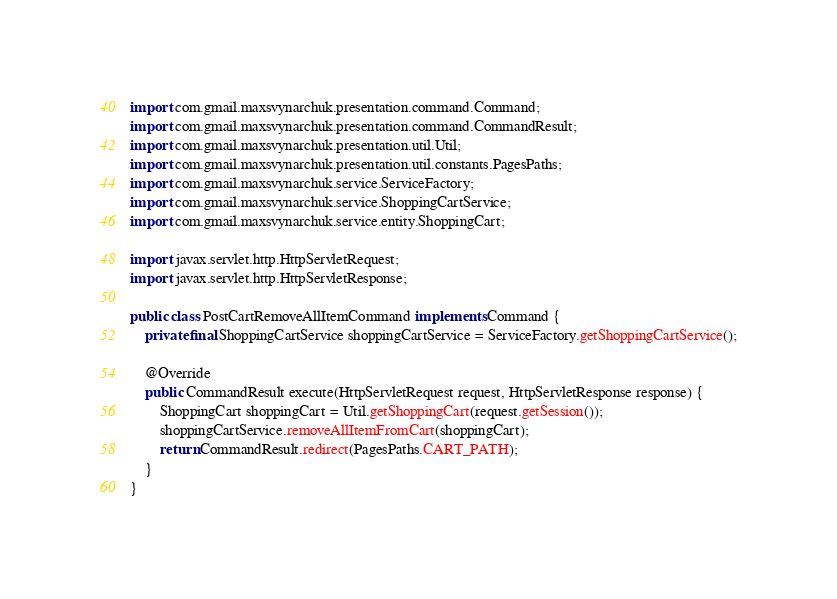<code> <loc_0><loc_0><loc_500><loc_500><_Java_>
import com.gmail.maxsvynarchuk.presentation.command.Command;
import com.gmail.maxsvynarchuk.presentation.command.CommandResult;
import com.gmail.maxsvynarchuk.presentation.util.Util;
import com.gmail.maxsvynarchuk.presentation.util.constants.PagesPaths;
import com.gmail.maxsvynarchuk.service.ServiceFactory;
import com.gmail.maxsvynarchuk.service.ShoppingCartService;
import com.gmail.maxsvynarchuk.service.entity.ShoppingCart;

import javax.servlet.http.HttpServletRequest;
import javax.servlet.http.HttpServletResponse;

public class PostCartRemoveAllItemCommand implements Command {
    private final ShoppingCartService shoppingCartService = ServiceFactory.getShoppingCartService();

    @Override
    public CommandResult execute(HttpServletRequest request, HttpServletResponse response) {
        ShoppingCart shoppingCart = Util.getShoppingCart(request.getSession());
        shoppingCartService.removeAllItemFromCart(shoppingCart);
        return CommandResult.redirect(PagesPaths.CART_PATH);
    }
}
</code> 